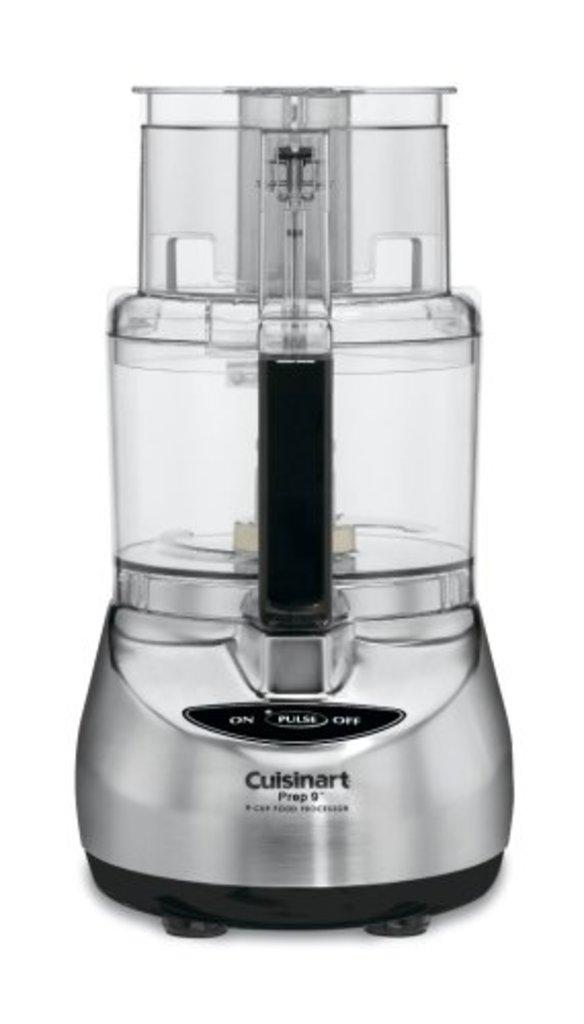<image>
Present a compact description of the photo's key features. A Cuisinart appliance that has nothing in it 